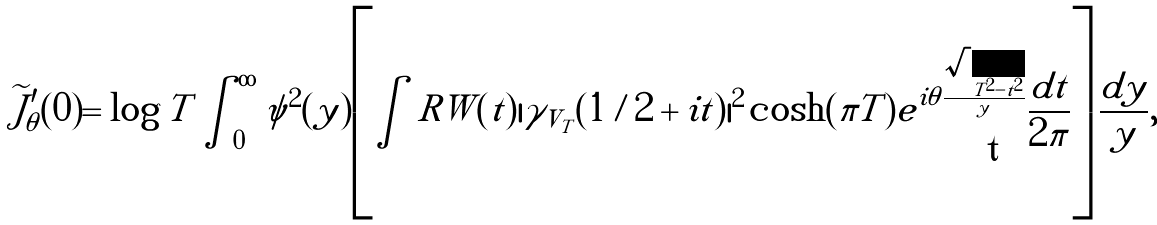Convert formula to latex. <formula><loc_0><loc_0><loc_500><loc_500>\widetilde { J } _ { \theta } ^ { \prime } ( 0 ) = \log T \int _ { 0 } ^ { \infty } \psi ^ { 2 } ( y ) \left [ \int R W ( t ) | \gamma _ { V _ { T } } ( 1 / 2 + i t ) | ^ { 2 } \cosh ( \pi T ) e ^ { i \theta \frac { \sqrt { T ^ { 2 } - t ^ { 2 } } } { y } } \frac { d t } { 2 \pi } \right ] \frac { d y } { y } ,</formula> 